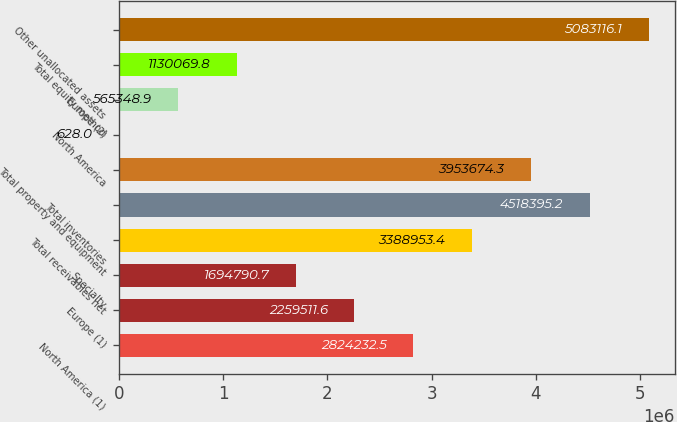Convert chart to OTSL. <chart><loc_0><loc_0><loc_500><loc_500><bar_chart><fcel>North America (1)<fcel>Europe (1)<fcel>Specialty<fcel>Total receivables net<fcel>Total inventories<fcel>Total property and equipment<fcel>North America<fcel>Europe (2)<fcel>Total equity method<fcel>Other unallocated assets<nl><fcel>2.82423e+06<fcel>2.25951e+06<fcel>1.69479e+06<fcel>3.38895e+06<fcel>4.5184e+06<fcel>3.95367e+06<fcel>628<fcel>565349<fcel>1.13007e+06<fcel>5.08312e+06<nl></chart> 